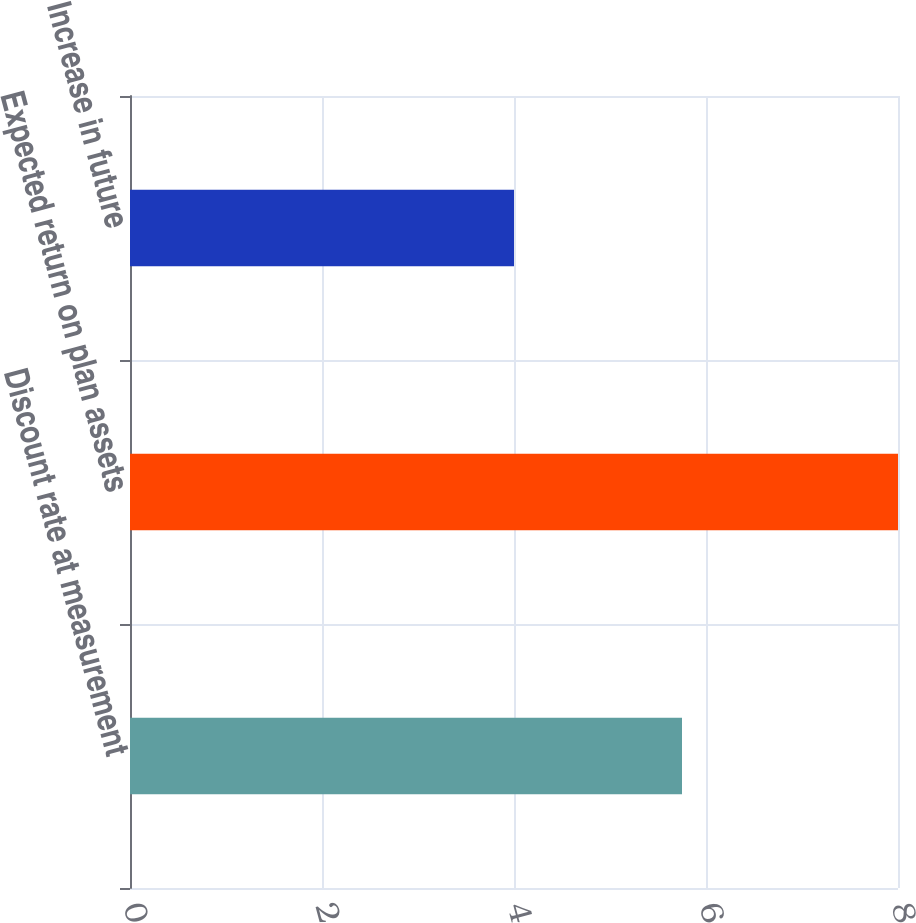<chart> <loc_0><loc_0><loc_500><loc_500><bar_chart><fcel>Discount rate at measurement<fcel>Expected return on plan assets<fcel>Increase in future<nl><fcel>5.75<fcel>8<fcel>4<nl></chart> 